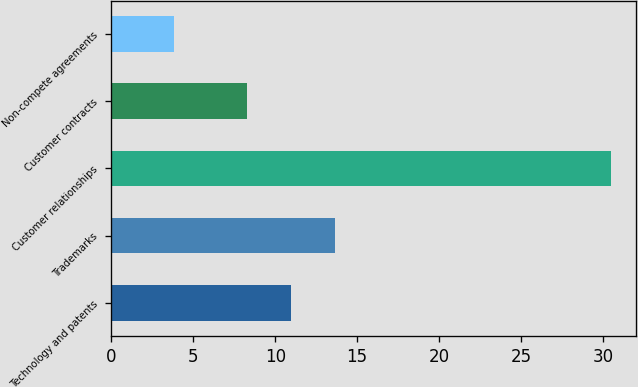Convert chart to OTSL. <chart><loc_0><loc_0><loc_500><loc_500><bar_chart><fcel>Technology and patents<fcel>Trademarks<fcel>Customer relationships<fcel>Customer contracts<fcel>Non-compete agreements<nl><fcel>10.97<fcel>13.64<fcel>30.5<fcel>8.3<fcel>3.8<nl></chart> 